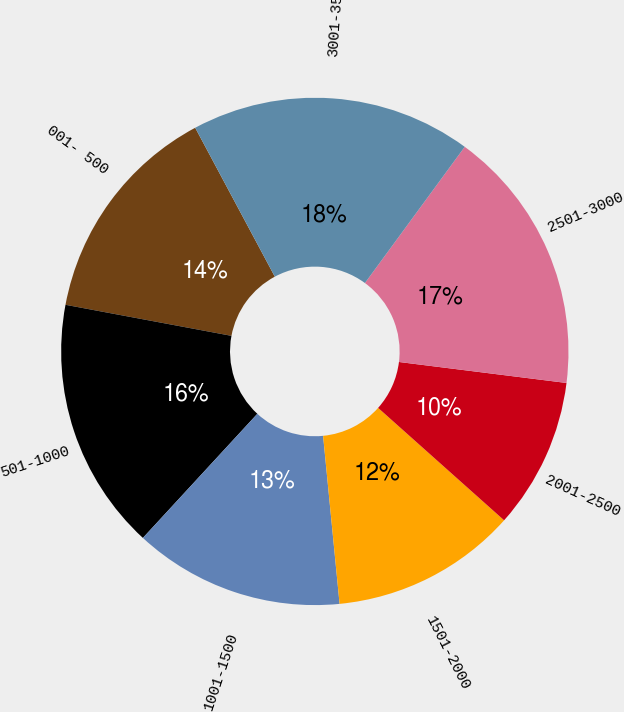Convert chart to OTSL. <chart><loc_0><loc_0><loc_500><loc_500><pie_chart><fcel>001- 500<fcel>501-1000<fcel>1001-1500<fcel>1501-2000<fcel>2001-2500<fcel>2501-3000<fcel>3001-3500<nl><fcel>14.24%<fcel>16.09%<fcel>13.41%<fcel>11.85%<fcel>9.61%<fcel>16.92%<fcel>17.88%<nl></chart> 